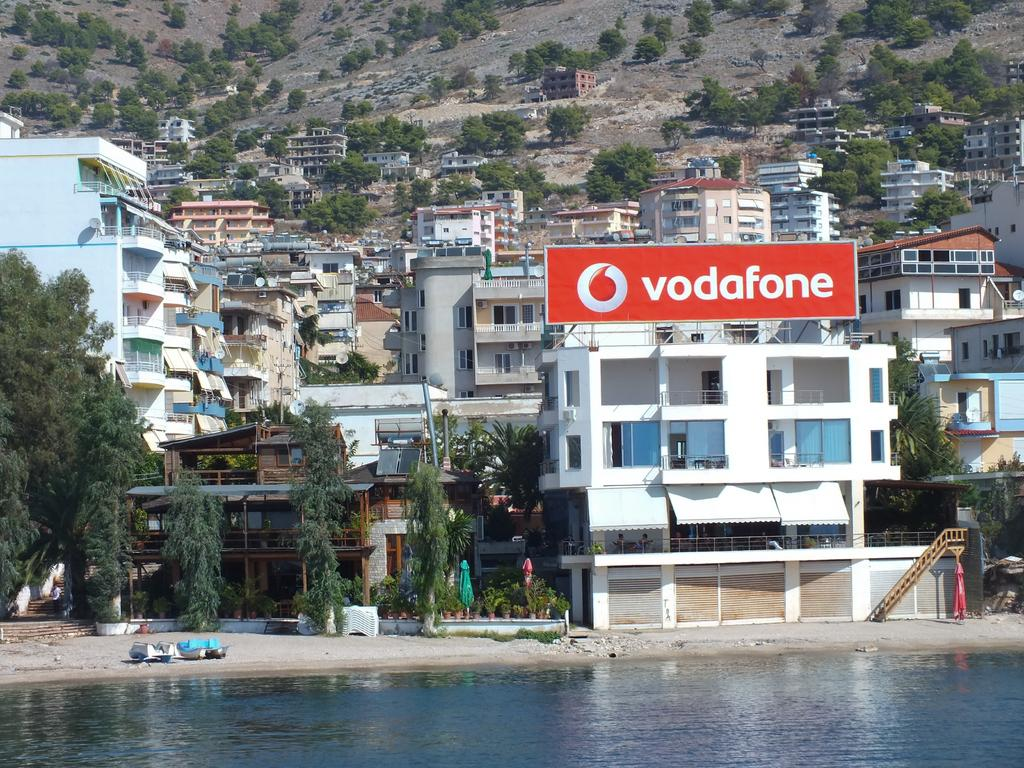What type of vegetation can be seen in the image? There are trees in the image. What type of structures are present in the image? There are buildings with windows in the image. What natural element is visible in the image? There is water visible in the image. What type of vehicles are on the ground in the image? There are boats on the ground in the image. What type of plants can be seen inside the buildings? There are house plants in the image. What type of signage is present in the image? There is a hoarding in the image. Where is the playground located in the image? There is no playground present in the image. 